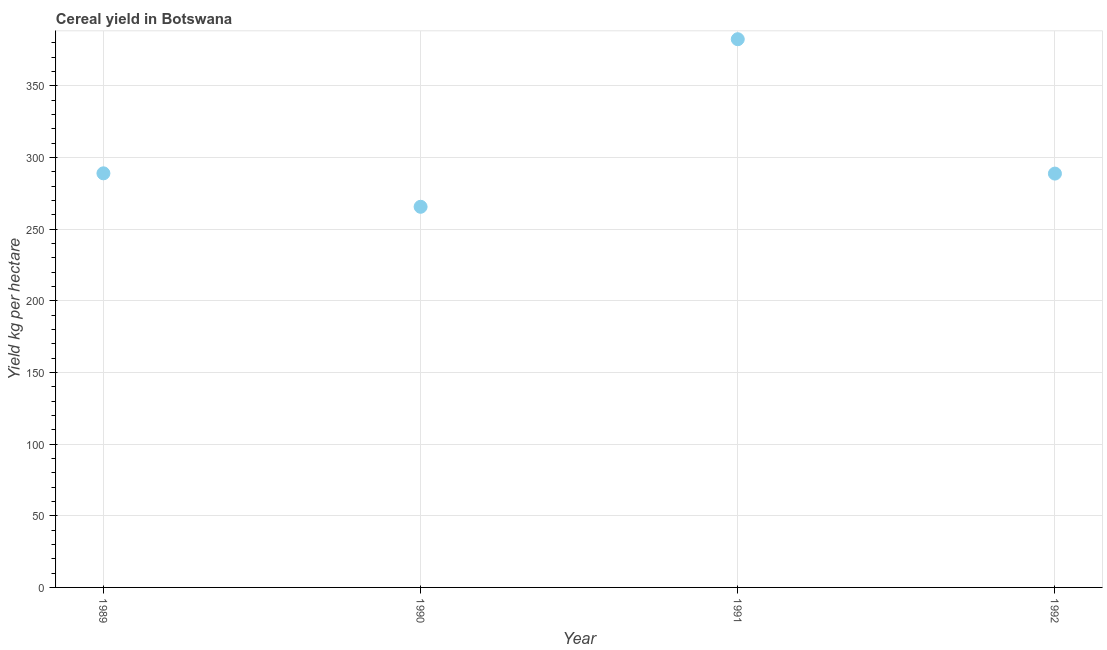What is the cereal yield in 1989?
Ensure brevity in your answer.  288.88. Across all years, what is the maximum cereal yield?
Keep it short and to the point. 382.44. Across all years, what is the minimum cereal yield?
Ensure brevity in your answer.  265.54. In which year was the cereal yield maximum?
Keep it short and to the point. 1991. What is the sum of the cereal yield?
Ensure brevity in your answer.  1225.55. What is the difference between the cereal yield in 1989 and 1991?
Provide a succinct answer. -93.56. What is the average cereal yield per year?
Ensure brevity in your answer.  306.39. What is the median cereal yield?
Keep it short and to the point. 288.78. What is the ratio of the cereal yield in 1989 to that in 1991?
Give a very brief answer. 0.76. Is the cereal yield in 1989 less than that in 1990?
Offer a terse response. No. Is the difference between the cereal yield in 1990 and 1991 greater than the difference between any two years?
Your answer should be very brief. Yes. What is the difference between the highest and the second highest cereal yield?
Ensure brevity in your answer.  93.56. Is the sum of the cereal yield in 1989 and 1990 greater than the maximum cereal yield across all years?
Make the answer very short. Yes. What is the difference between the highest and the lowest cereal yield?
Your response must be concise. 116.9. In how many years, is the cereal yield greater than the average cereal yield taken over all years?
Offer a terse response. 1. Are the values on the major ticks of Y-axis written in scientific E-notation?
Offer a terse response. No. Does the graph contain any zero values?
Offer a very short reply. No. Does the graph contain grids?
Give a very brief answer. Yes. What is the title of the graph?
Your answer should be very brief. Cereal yield in Botswana. What is the label or title of the X-axis?
Offer a terse response. Year. What is the label or title of the Y-axis?
Make the answer very short. Yield kg per hectare. What is the Yield kg per hectare in 1989?
Your response must be concise. 288.88. What is the Yield kg per hectare in 1990?
Provide a short and direct response. 265.54. What is the Yield kg per hectare in 1991?
Provide a succinct answer. 382.44. What is the Yield kg per hectare in 1992?
Make the answer very short. 288.69. What is the difference between the Yield kg per hectare in 1989 and 1990?
Offer a very short reply. 23.34. What is the difference between the Yield kg per hectare in 1989 and 1991?
Give a very brief answer. -93.56. What is the difference between the Yield kg per hectare in 1989 and 1992?
Provide a succinct answer. 0.19. What is the difference between the Yield kg per hectare in 1990 and 1991?
Offer a terse response. -116.91. What is the difference between the Yield kg per hectare in 1990 and 1992?
Your answer should be compact. -23.16. What is the difference between the Yield kg per hectare in 1991 and 1992?
Offer a terse response. 93.75. What is the ratio of the Yield kg per hectare in 1989 to that in 1990?
Ensure brevity in your answer.  1.09. What is the ratio of the Yield kg per hectare in 1989 to that in 1991?
Keep it short and to the point. 0.76. What is the ratio of the Yield kg per hectare in 1990 to that in 1991?
Offer a very short reply. 0.69. What is the ratio of the Yield kg per hectare in 1991 to that in 1992?
Your answer should be compact. 1.32. 